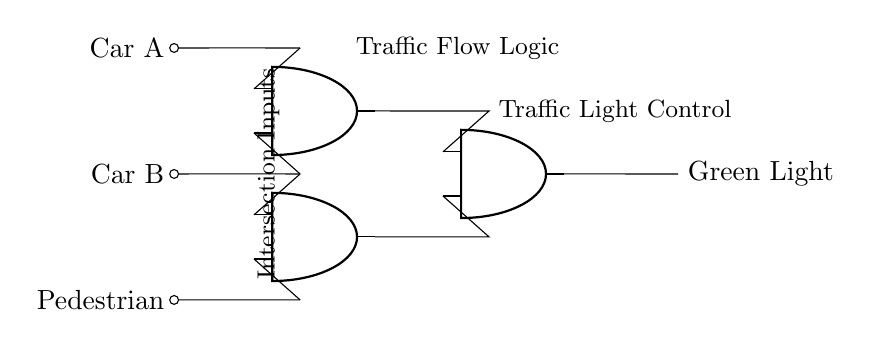What components are used in this circuit? The circuit contains AND gates and input signals labeled Car A, Car B, and Pedestrian. These inputs connect to AND gates for traffic light control.
Answer: AND gates, input signals What is the output of the circuit? The output is labeled as Green Light, indicating the action that will occur based on the AND conditions met by the inputs.
Answer: Green Light How many AND gates are present in the circuit? The circuit has three AND gates indicated in different positions, each handling different input combinations for decision making.
Answer: Three Which inputs are connected to the first AND gate? The first AND gate has connections from Car A and Car B, ensuring that both must be present for the output condition to be true.
Answer: Car A, Car B What condition must be met for the Green Light to be activated? The Green Light is activated when both Car A and Car B are present, as indicated by the first AND gate's output.
Answer: Both Car A and Car B Which input is connected to the second AND gate? The second AND gate takes its inputs from Car B and Pedestrian, allowing pedestrian presence to be considered along with traffic flow.
Answer: Car B, Pedestrian How does the final AND gate function in this circuit? The final AND gate combines outputs from the first and the second AND gates, requiring both conditions to evaluate true for the Green Light to activate.
Answer: Combines outputs from first and second AND gates 